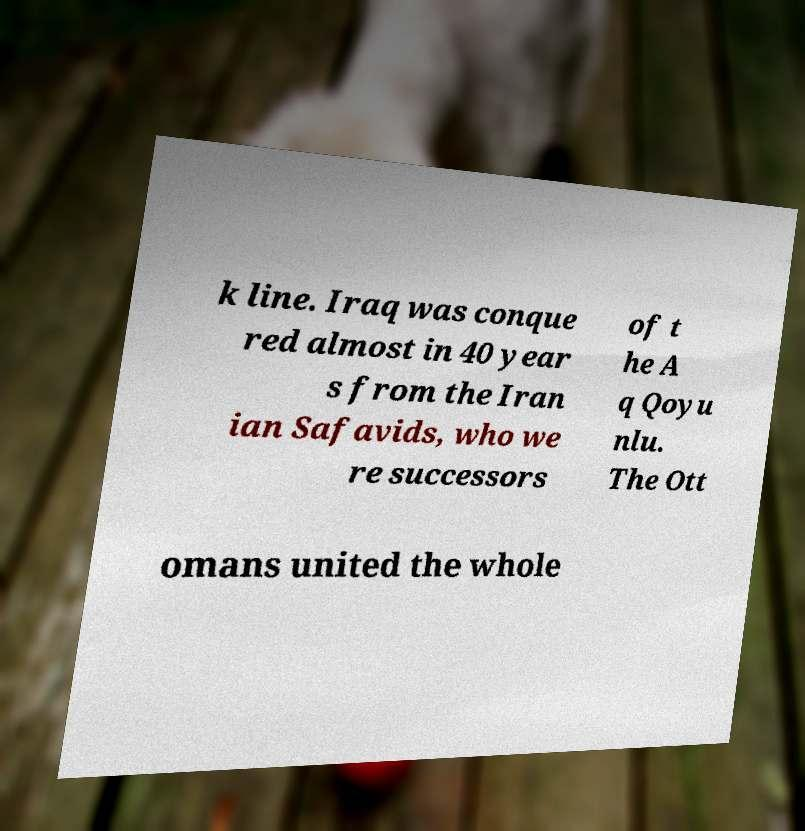Please read and relay the text visible in this image. What does it say? k line. Iraq was conque red almost in 40 year s from the Iran ian Safavids, who we re successors of t he A q Qoyu nlu. The Ott omans united the whole 